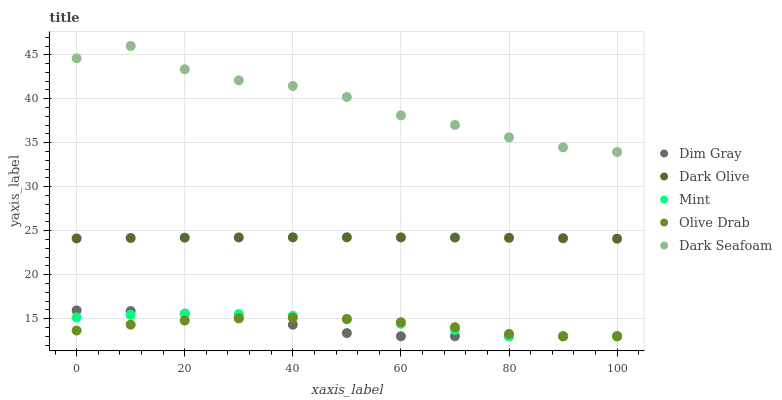Does Dim Gray have the minimum area under the curve?
Answer yes or no. Yes. Does Dark Seafoam have the maximum area under the curve?
Answer yes or no. Yes. Does Dark Seafoam have the minimum area under the curve?
Answer yes or no. No. Does Dim Gray have the maximum area under the curve?
Answer yes or no. No. Is Dark Olive the smoothest?
Answer yes or no. Yes. Is Dark Seafoam the roughest?
Answer yes or no. Yes. Is Dim Gray the smoothest?
Answer yes or no. No. Is Dim Gray the roughest?
Answer yes or no. No. Does Dim Gray have the lowest value?
Answer yes or no. Yes. Does Dark Seafoam have the lowest value?
Answer yes or no. No. Does Dark Seafoam have the highest value?
Answer yes or no. Yes. Does Dim Gray have the highest value?
Answer yes or no. No. Is Dim Gray less than Dark Seafoam?
Answer yes or no. Yes. Is Dark Seafoam greater than Dim Gray?
Answer yes or no. Yes. Does Dim Gray intersect Mint?
Answer yes or no. Yes. Is Dim Gray less than Mint?
Answer yes or no. No. Is Dim Gray greater than Mint?
Answer yes or no. No. Does Dim Gray intersect Dark Seafoam?
Answer yes or no. No. 